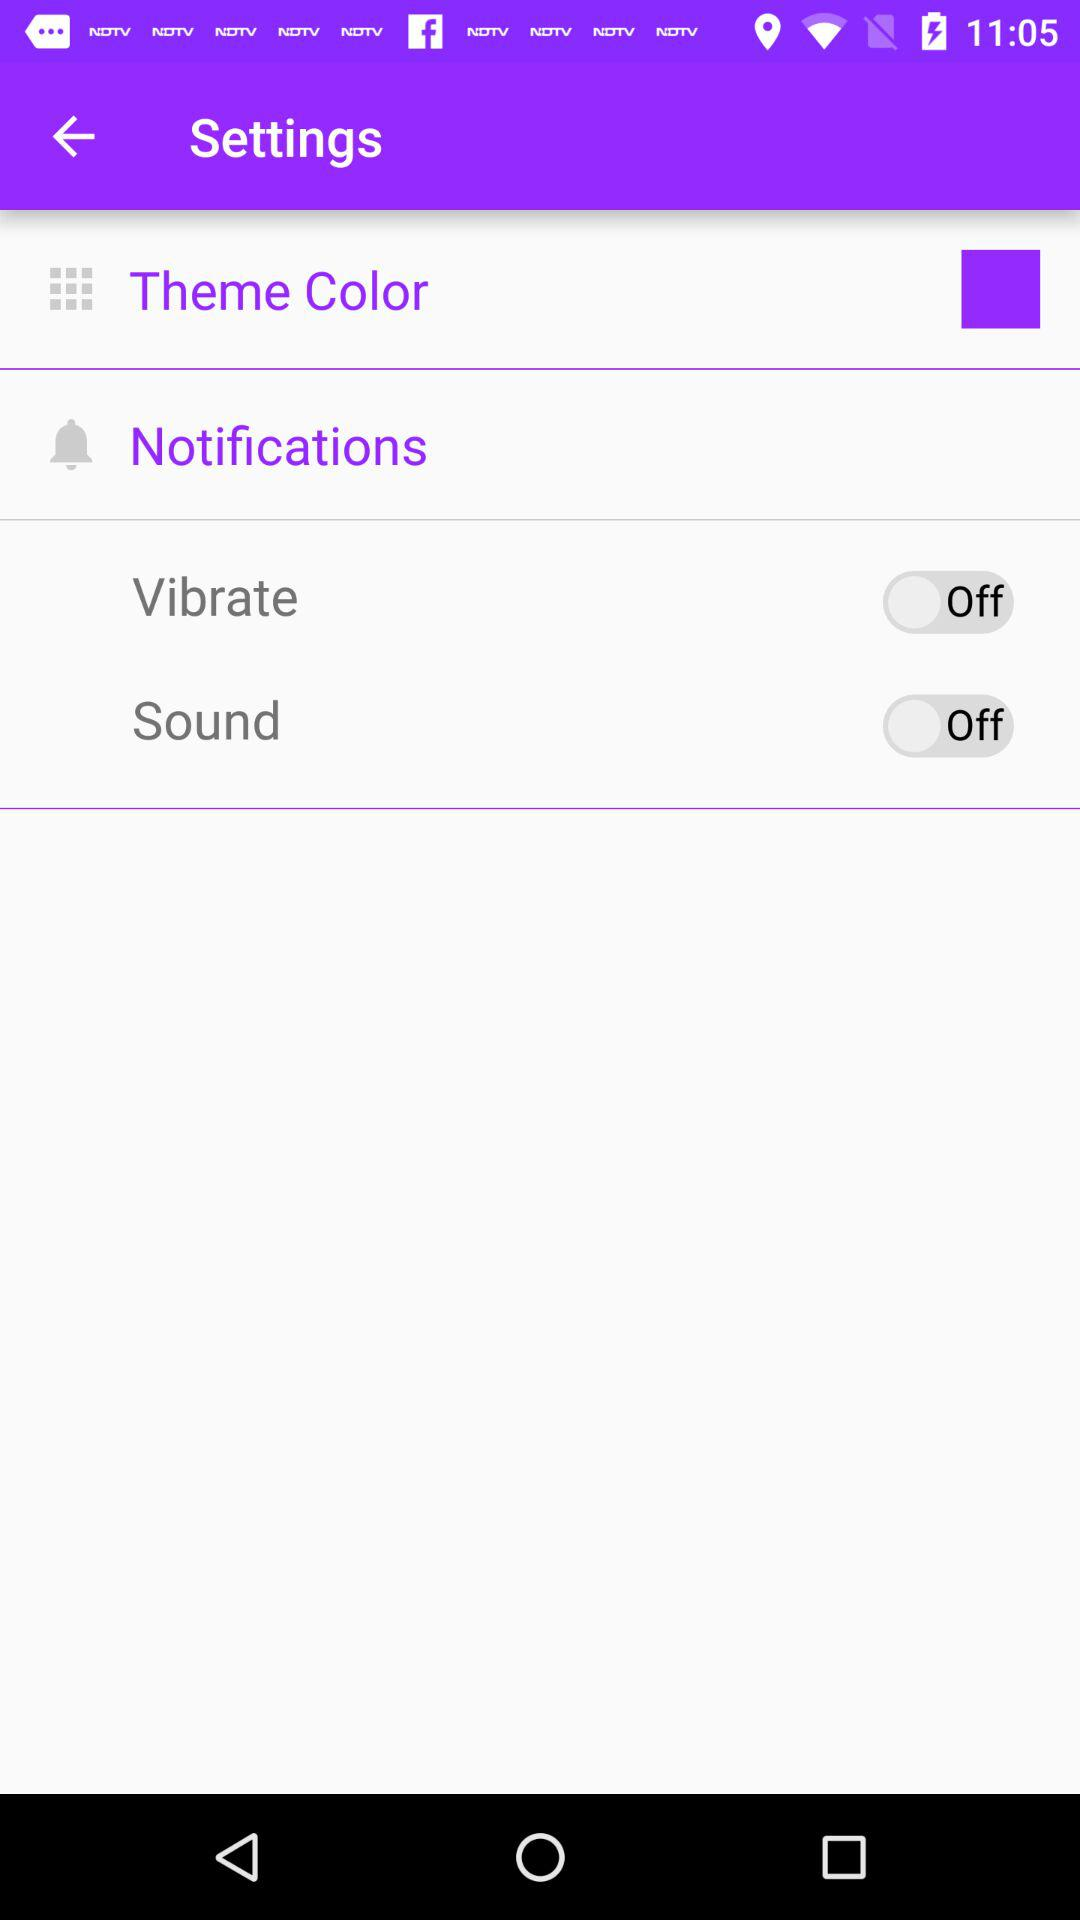Which theme is selected?
When the provided information is insufficient, respond with <no answer>. <no answer> 